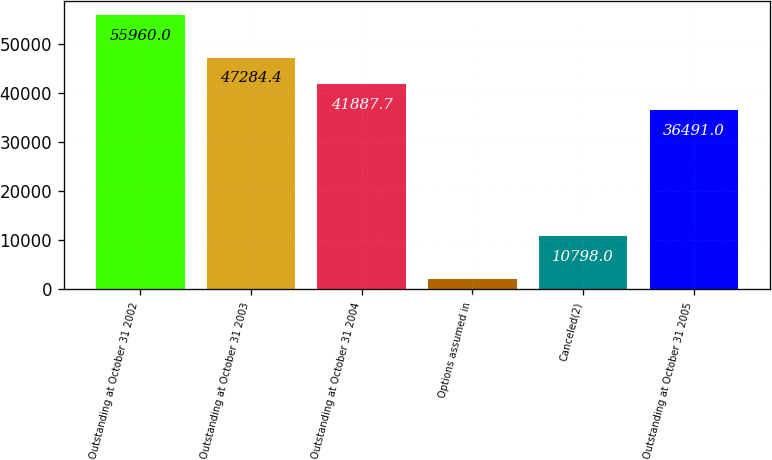<chart> <loc_0><loc_0><loc_500><loc_500><bar_chart><fcel>Outstanding at October 31 2002<fcel>Outstanding at October 31 2003<fcel>Outstanding at October 31 2004<fcel>Options assumed in<fcel>Canceled(2)<fcel>Outstanding at October 31 2005<nl><fcel>55960<fcel>47284.4<fcel>41887.7<fcel>1993<fcel>10798<fcel>36491<nl></chart> 